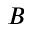Convert formula to latex. <formula><loc_0><loc_0><loc_500><loc_500>B</formula> 